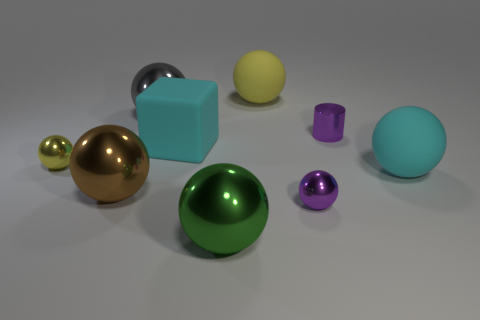Subtract all large yellow balls. How many balls are left? 6 Subtract 4 balls. How many balls are left? 3 Subtract all yellow balls. How many balls are left? 5 Subtract all yellow spheres. Subtract all red blocks. How many spheres are left? 5 Subtract all spheres. How many objects are left? 2 Subtract all purple metal things. Subtract all small cyan shiny cylinders. How many objects are left? 7 Add 4 blocks. How many blocks are left? 5 Add 3 small brown metal cubes. How many small brown metal cubes exist? 3 Subtract 0 red blocks. How many objects are left? 9 